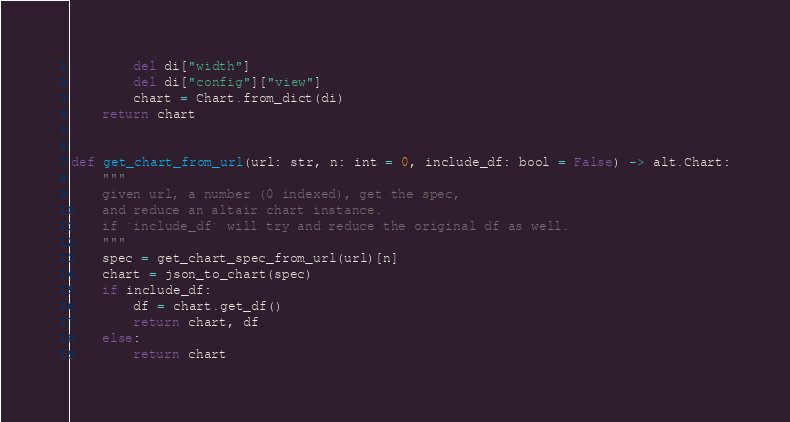Convert code to text. <code><loc_0><loc_0><loc_500><loc_500><_Python_>        del di["width"]
        del di["config"]["view"]
        chart = Chart.from_dict(di)
    return chart


def get_chart_from_url(url: str, n: int = 0, include_df: bool = False) -> alt.Chart:
    """
    given url, a number (0 indexed), get the spec,
    and reduce an altair chart instance.
    if `include_df` will try and reduce the original df as well.
    """
    spec = get_chart_spec_from_url(url)[n]
    chart = json_to_chart(spec)
    if include_df:
        df = chart.get_df()
        return chart, df
    else:
        return chart
</code> 